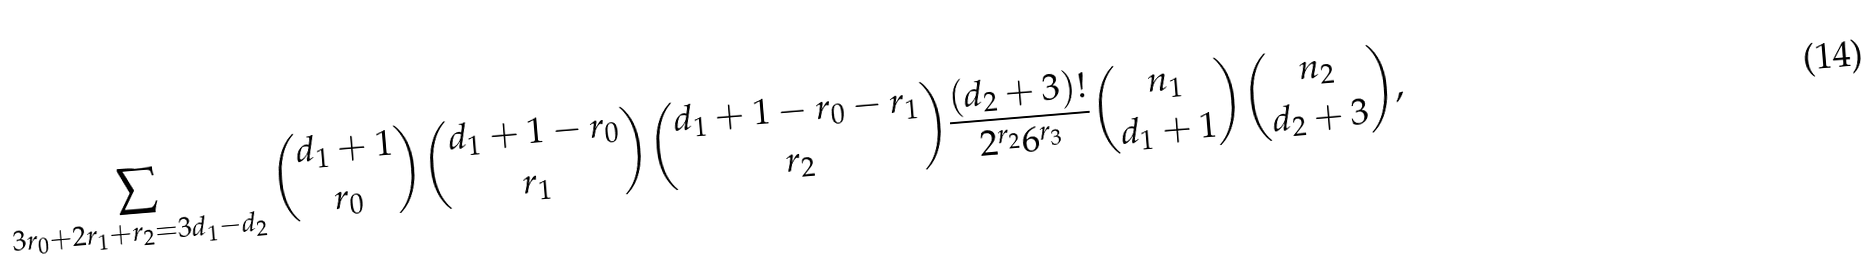<formula> <loc_0><loc_0><loc_500><loc_500>\sum _ { 3 r _ { 0 } + 2 r _ { 1 } + r _ { 2 } = 3 d _ { 1 } - d _ { 2 } } { d _ { 1 } + 1 \choose r _ { 0 } } { d _ { 1 } + 1 - r _ { 0 } \choose r _ { 1 } } { d _ { 1 } + 1 - r _ { 0 } - r _ { 1 } \choose r _ { 2 } } \frac { ( d _ { 2 } + 3 ) ! } { 2 ^ { r _ { 2 } } 6 ^ { r _ { 3 } } } { n _ { 1 } \choose d _ { 1 } + 1 } { n _ { 2 } \choose d _ { 2 } + 3 } ,</formula> 